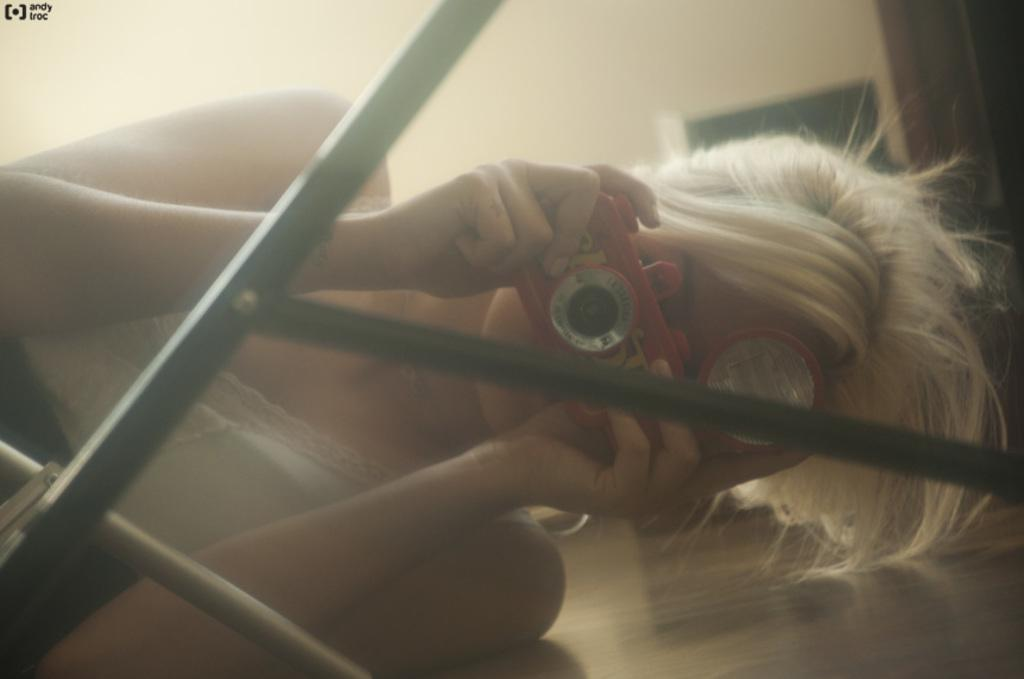Who is the main subject in the image? There is a woman in the image. What is the woman doing in the image? The woman is laying on the floor. What is the woman holding in her hands? The woman is holding a camera in her hands. What is the woman wearing in the image? The woman is wearing a white dress. What can be seen in the background of the image? There is a wall in the background of the image. What type of engine can be seen in the woman's vein in the image? There is no engine or vein visible in the image; it features a woman laying on the floor while holding a camera. 